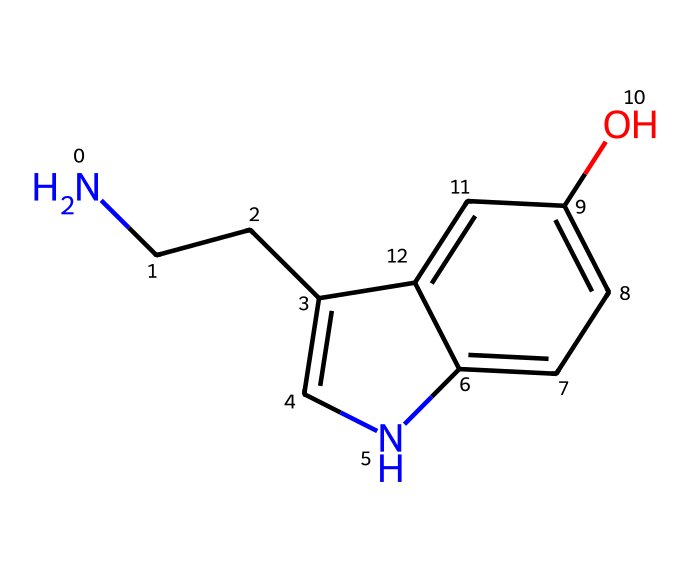What is the molecular formula of serotonin? By analyzing the SMILES representation, we can identify all the atoms present. Counting the atoms, we find: 10 carbon (C), 12 hydrogen (H), 2 nitrogen (N), and 1 oxygen (O) atom. Thus, the molecular formula combines these counts.
Answer: C10H12N2O How many rings are present in serotonin's chemical structure? In examining the SMILES, we can see that the structure contains two parts with 'c' and 'n', indicating a connection between aromatic and heterocyclic components, which form two rings in its structure.
Answer: 2 What type of functional group is present in serotonin? The presence of the hydroxyl group (-OH) indicated by 'O' in the SMILES suggests that serotonin contains an alcohol functional group, making it soluble in water and altering its chemical properties.
Answer: Alcohol Is serotonin a polar or non-polar molecule? Considering the presence of functional groups like the -OH (hydroxyl) group and the amine (NH) group from 'NCC', the molecule exhibits polarity due to the ability of these groups to form hydrogen bonds with water.
Answer: Polar What type of amine is found in serotonin? The structure shows that the nitrogen atom is connected to both two hydrogen atoms and a carbon chain, indicating it is a primary amine, which means it is bound to one carbon atom with two hydrogen atoms attached to it.
Answer: Primary amine 